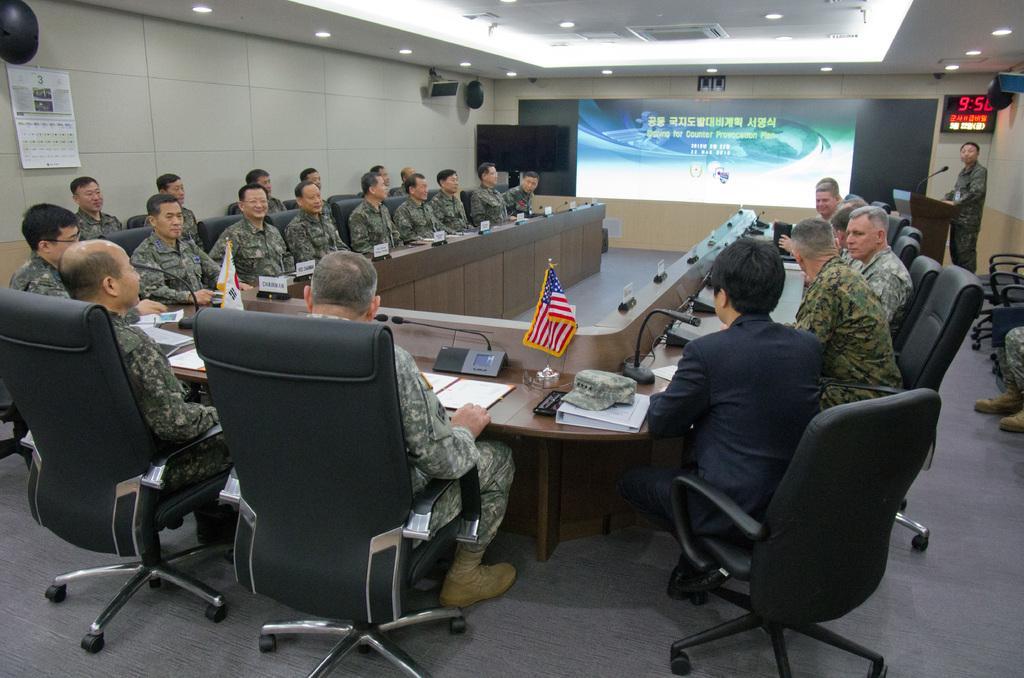Describe this image in one or two sentences. As we can see in the image there is a calendar, wall, screen, few people sitting on chairs and there is a table. On table there is a cap, boom, mic and phone 